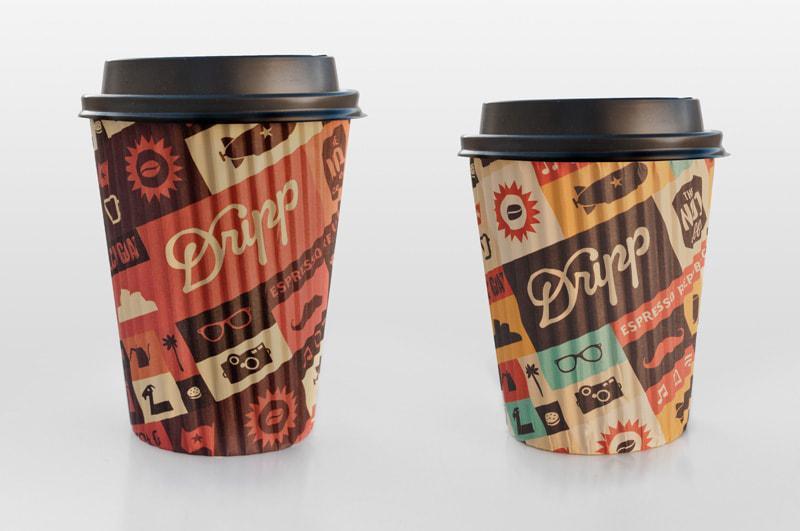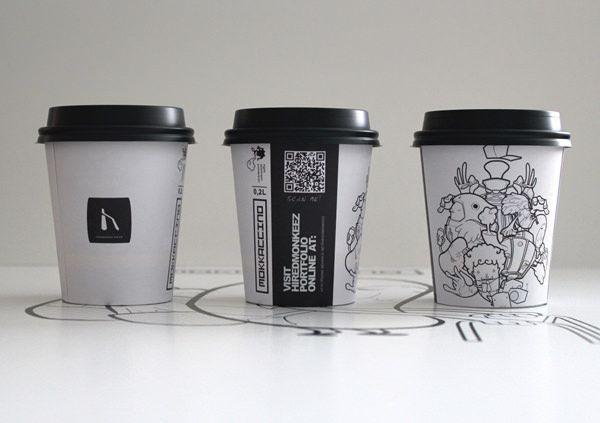The first image is the image on the left, the second image is the image on the right. For the images shown, is this caption "There are five coffee cups." true? Answer yes or no. Yes. The first image is the image on the left, the second image is the image on the right. Analyze the images presented: Is the assertion "There are exactly five cups." valid? Answer yes or no. Yes. 